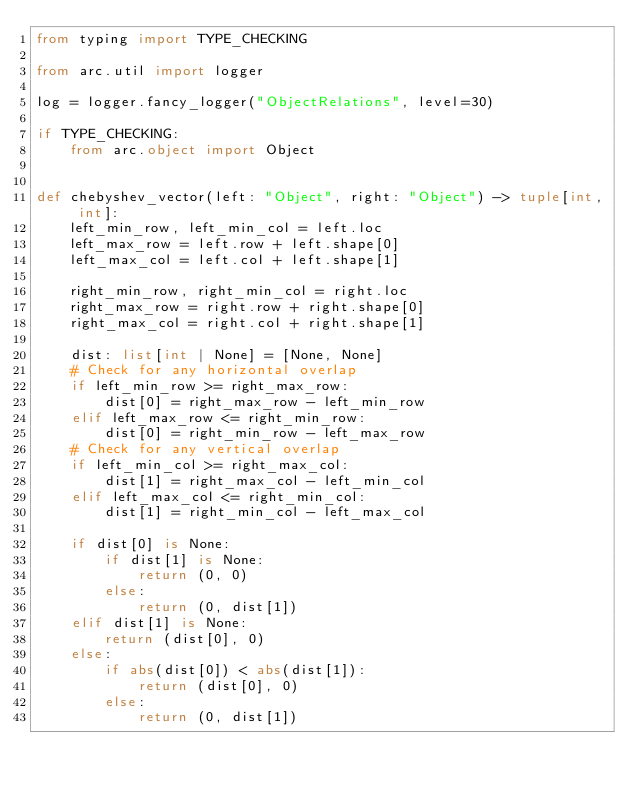<code> <loc_0><loc_0><loc_500><loc_500><_Python_>from typing import TYPE_CHECKING

from arc.util import logger

log = logger.fancy_logger("ObjectRelations", level=30)

if TYPE_CHECKING:
    from arc.object import Object


def chebyshev_vector(left: "Object", right: "Object") -> tuple[int, int]:
    left_min_row, left_min_col = left.loc
    left_max_row = left.row + left.shape[0]
    left_max_col = left.col + left.shape[1]

    right_min_row, right_min_col = right.loc
    right_max_row = right.row + right.shape[0]
    right_max_col = right.col + right.shape[1]

    dist: list[int | None] = [None, None]
    # Check for any horizontal overlap
    if left_min_row >= right_max_row:
        dist[0] = right_max_row - left_min_row
    elif left_max_row <= right_min_row:
        dist[0] = right_min_row - left_max_row
    # Check for any vertical overlap
    if left_min_col >= right_max_col:
        dist[1] = right_max_col - left_min_col
    elif left_max_col <= right_min_col:
        dist[1] = right_min_col - left_max_col

    if dist[0] is None:
        if dist[1] is None:
            return (0, 0)
        else:
            return (0, dist[1])
    elif dist[1] is None:
        return (dist[0], 0)
    else:
        if abs(dist[0]) < abs(dist[1]):
            return (dist[0], 0)
        else:
            return (0, dist[1])
</code> 